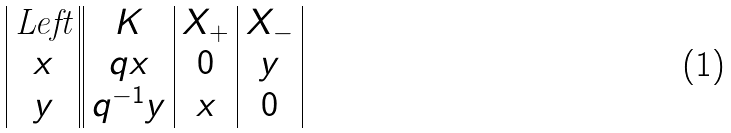<formula> <loc_0><loc_0><loc_500><loc_500>\begin{array} { | c | | c | c | c | } \text {Left} & K & X _ { + } & X _ { - } \\ x & q x & 0 & y \\ y & q ^ { - 1 } y & x & 0 \\ \end{array}</formula> 